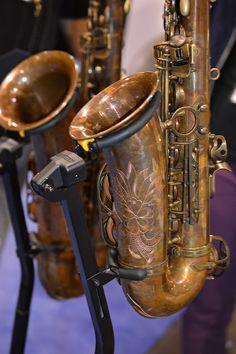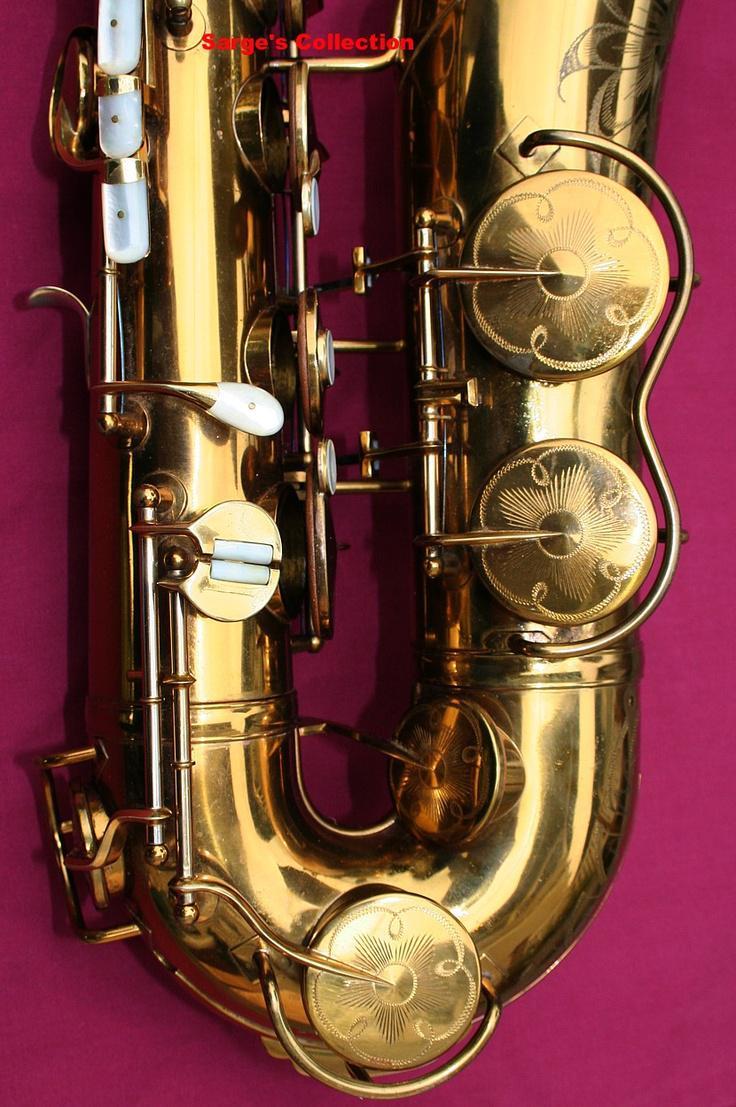The first image is the image on the left, the second image is the image on the right. Given the left and right images, does the statement "The combined images include an open case, a saxophone displayed horizontally, and a saxophone displayed diagonally." hold true? Answer yes or no. No. The first image is the image on the left, the second image is the image on the right. Analyze the images presented: Is the assertion "One sax is laying exactly horizontally." valid? Answer yes or no. No. 